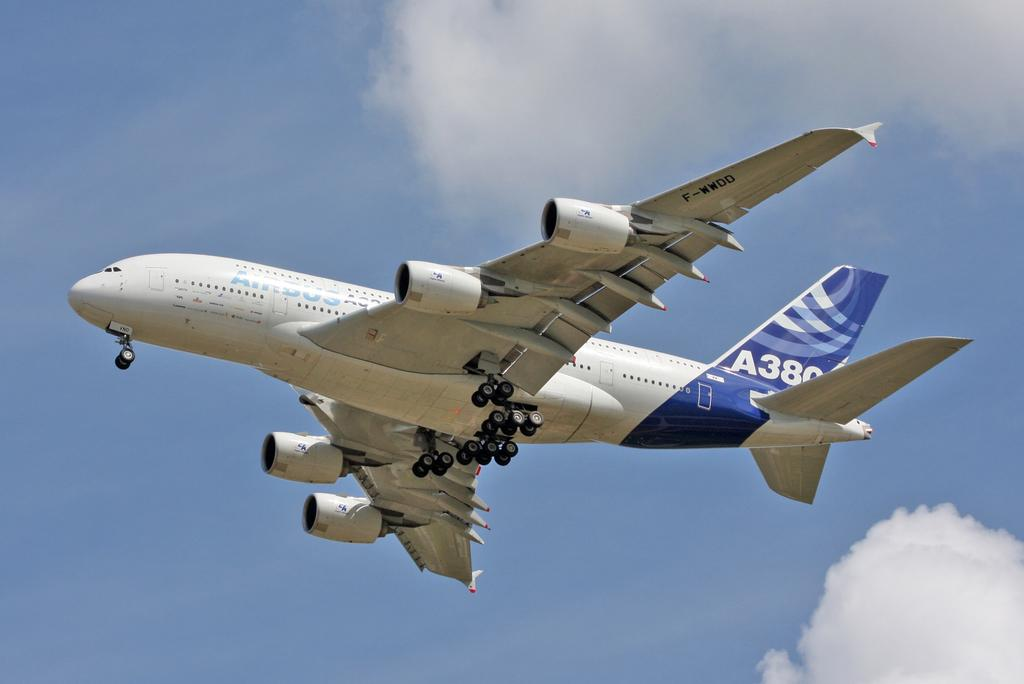Provide a one-sentence caption for the provided image. An airplane is flying in the air with an A on the tail followed by a number. 